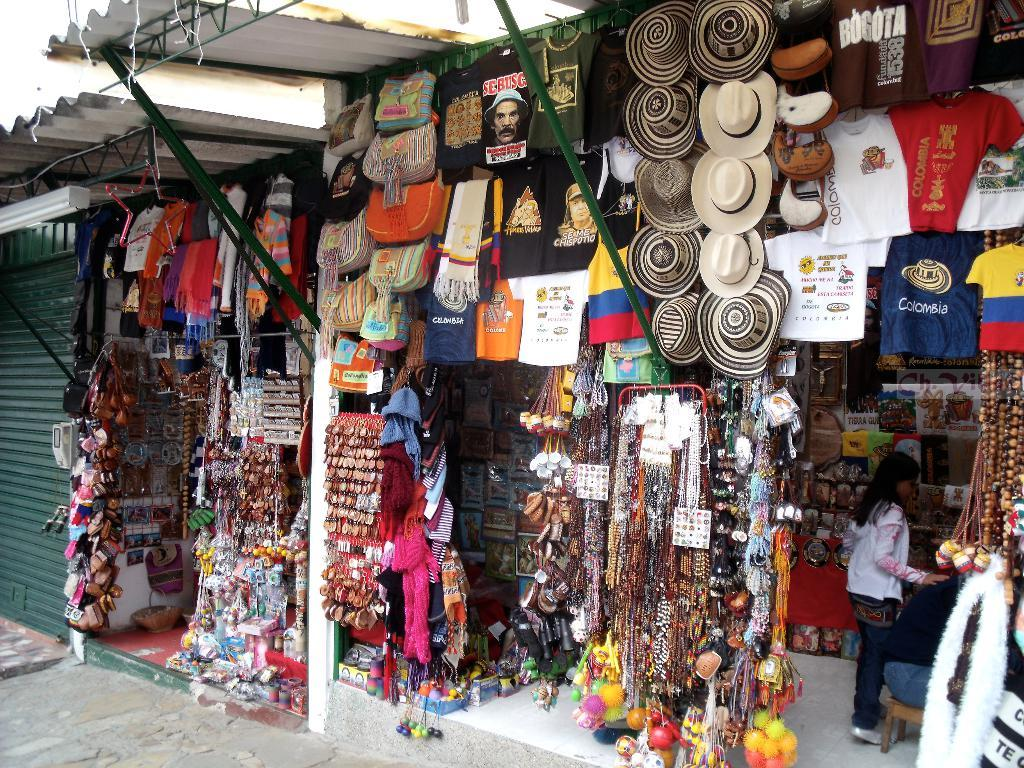Who is present in the image? There is a woman in the image. What type of stores can be seen in the image? There are two stores in the image. What items are sold in these stores? The stores sell caps, shirts, ornaments, keychains, and scarves. What type of wool is used to make the scarves in the image? There is no information about the type of wool used to make the scarves in the image. 